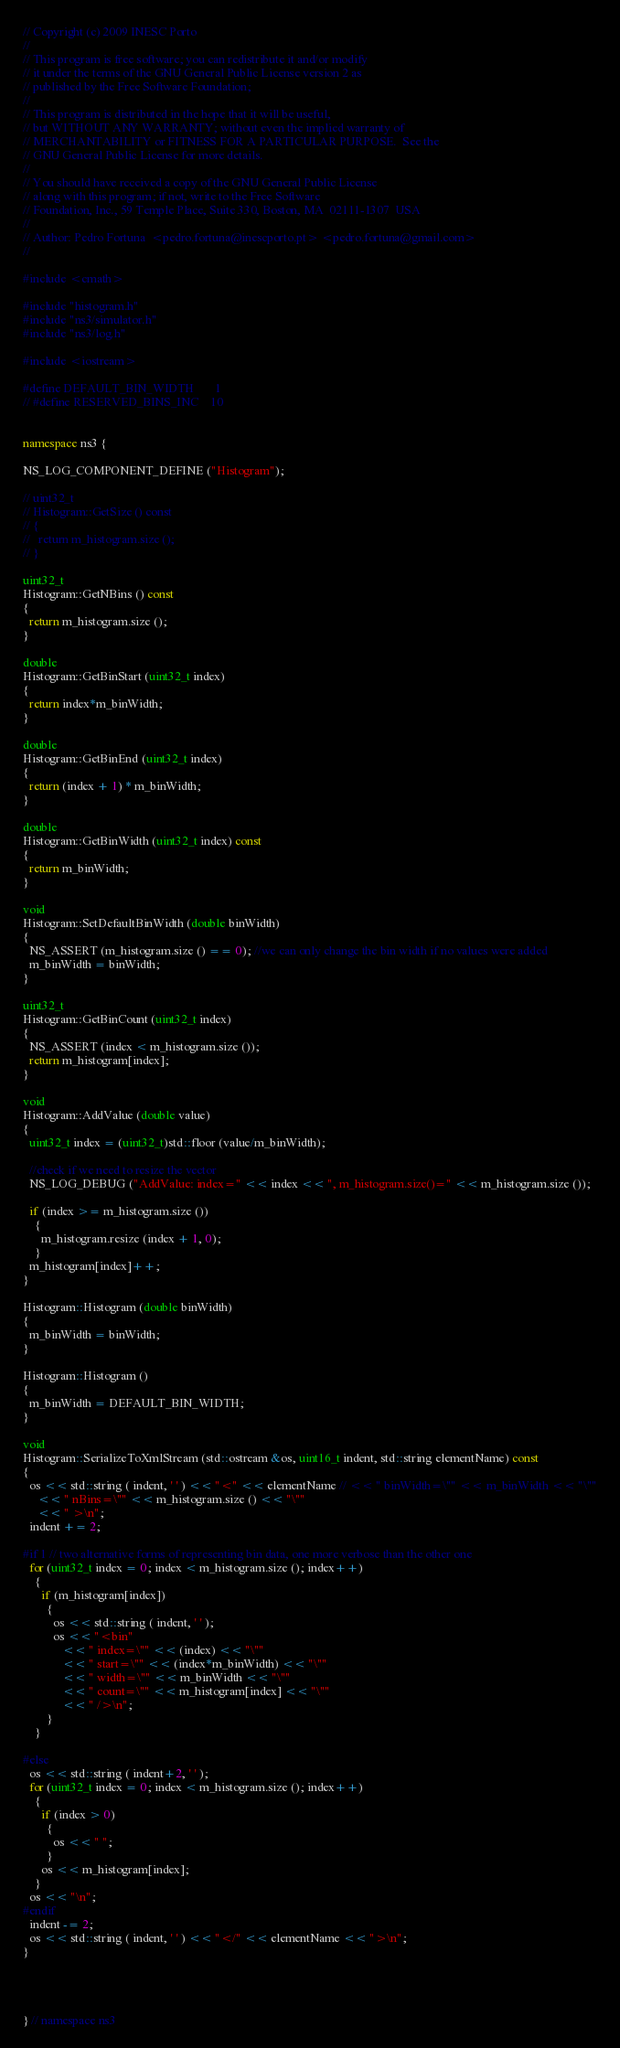Convert code to text. <code><loc_0><loc_0><loc_500><loc_500><_C++_>// Copyright (c) 2009 INESC Porto
//
// This program is free software; you can redistribute it and/or modify
// it under the terms of the GNU General Public License version 2 as
// published by the Free Software Foundation;
//
// This program is distributed in the hope that it will be useful,
// but WITHOUT ANY WARRANTY; without even the implied warranty of
// MERCHANTABILITY or FITNESS FOR A PARTICULAR PURPOSE.  See the
// GNU General Public License for more details.
//
// You should have received a copy of the GNU General Public License
// along with this program; if not, write to the Free Software
// Foundation, Inc., 59 Temple Place, Suite 330, Boston, MA  02111-1307  USA
//
// Author: Pedro Fortuna  <pedro.fortuna@inescporto.pt> <pedro.fortuna@gmail.com>
//

#include <cmath>

#include "histogram.h"
#include "ns3/simulator.h"
#include "ns3/log.h"

#include <iostream>

#define DEFAULT_BIN_WIDTH       1
// #define RESERVED_BINS_INC	10


namespace ns3 {

NS_LOG_COMPONENT_DEFINE ("Histogram");

// uint32_t 
// Histogram::GetSize () const
// {
//   return m_histogram.size ();
// }

uint32_t 
Histogram::GetNBins () const
{
  return m_histogram.size ();
}

double 
Histogram::GetBinStart (uint32_t index)
{
  return index*m_binWidth;
}

double 
Histogram::GetBinEnd (uint32_t index)
{
  return (index + 1) * m_binWidth;
}

double 
Histogram::GetBinWidth (uint32_t index) const
{
  return m_binWidth;
}

void 
Histogram::SetDefaultBinWidth (double binWidth)
{
  NS_ASSERT (m_histogram.size () == 0); //we can only change the bin width if no values were added
  m_binWidth = binWidth;
}

uint32_t 
Histogram::GetBinCount (uint32_t index) 
{
  NS_ASSERT (index < m_histogram.size ());
  return m_histogram[index];
}

void 
Histogram::AddValue (double value)
{
  uint32_t index = (uint32_t)std::floor (value/m_binWidth);

  //check if we need to resize the vector
  NS_LOG_DEBUG ("AddValue: index=" << index << ", m_histogram.size()=" << m_histogram.size ());

  if (index >= m_histogram.size ())
    {
      m_histogram.resize (index + 1, 0);
    }
  m_histogram[index]++;
}

Histogram::Histogram (double binWidth)
{
  m_binWidth = binWidth;
}

Histogram::Histogram ()
{
  m_binWidth = DEFAULT_BIN_WIDTH;
}

void
Histogram::SerializeToXmlStream (std::ostream &os, uint16_t indent, std::string elementName) const
{
  os << std::string ( indent, ' ' ) << "<" << elementName // << " binWidth=\"" << m_binWidth << "\""
     << " nBins=\"" << m_histogram.size () << "\""
     << " >\n";
  indent += 2;

#if 1 // two alternative forms of representing bin data, one more verbose than the other one
  for (uint32_t index = 0; index < m_histogram.size (); index++)
    {
      if (m_histogram[index])
        {
          os << std::string ( indent, ' ' );
          os << "<bin"
             << " index=\"" << (index) << "\""
             << " start=\"" << (index*m_binWidth) << "\""
             << " width=\"" << m_binWidth << "\""
             << " count=\"" << m_histogram[index] << "\""
             << " />\n";
        }
    }

#else
  os << std::string ( indent+2, ' ' );
  for (uint32_t index = 0; index < m_histogram.size (); index++)
    {
      if (index > 0)
        {
          os << " ";
        }
      os << m_histogram[index];
    }
  os << "\n";
#endif
  indent -= 2;
  os << std::string ( indent, ' ' ) << "</" << elementName << ">\n";
}




} // namespace ns3


</code> 